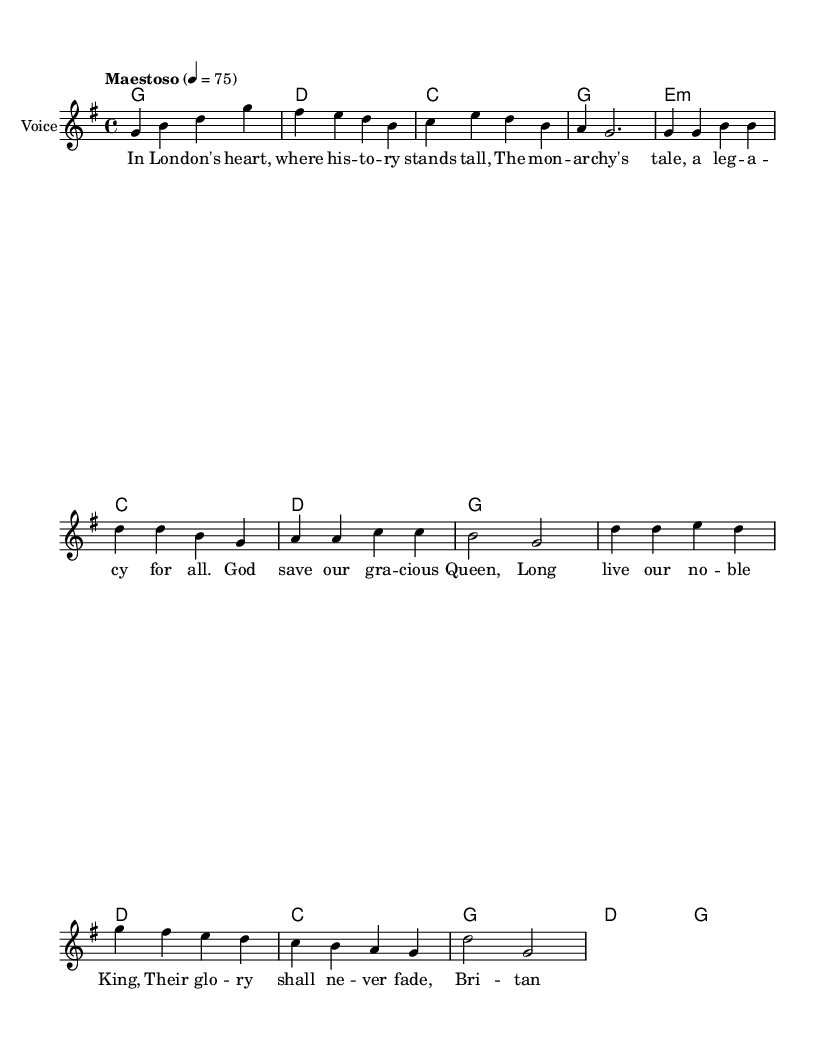What is the key signature of this music? The key signature is identified by the number of sharps or flats at the beginning of the staff. In this case, there are no sharps or flats listed, indicating that it is in G major, which contains one sharp (F#). However, the music specifically indicates G major.
Answer: G major What is the time signature of this piece? The time signature can be found at the beginning of the music sheet, indicating the number of beats per measure. Here, it is marked as 4/4, meaning there are four beats in each measure.
Answer: 4/4 What is the tempo marking? The tempo marking is given above the music, specifying the speed at which the piece should be played. In this case, it is indicated as "Maestoso," suggesting a stately and majestic pace. The numerical indication specifies a speed of 75 beats per minute.
Answer: Maestoso How many measures are in the introduction? The introduction comprises the first part of the music before the verse begins. Counting the measures visually in this section, we find there are four distinct measures.
Answer: Four What is the main theme of the lyrics? To determine the main theme of the lyrics, we can read through the text of the verse and chorus provided. They clearly express a connection to the monarchy and patriotic sentiments about the history of Britain. This consistent theme focuses on honoring the Queen and the legacy of the monarchy.
Answer: The monarchy's legacy What instruments are indicated in the score? The instruments are typically mentioned at the start of each staff in the music sheet. Here, it is designated as "Voice," meaning it is primarily composed for the vocal performance. No other instruments are listed, focusing solely on the soloist.
Answer: Voice How many verses are in this opera piece? By examining the lyrics section, we can identify that there is one complete verse followed by a chorus. This shows the structure commonly found in operatic compositions where verses and choruses alternate.
Answer: One 